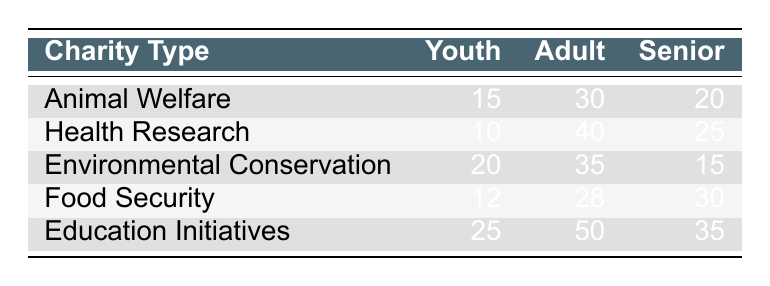What is the donation amount from Seniors to Food Security? In the table, the donation amount from Seniors for Food Security is indicated directly as 30.
Answer: 30 Which charity type received the highest donation from Adults? By looking across the Adult column, Education Initiatives has the highest amount of 50 compared to other charity types.
Answer: Education Initiatives What is the average donation amount from Youth across all charity types? To find the average, sum the values in the Youth column (15 + 10 + 20 + 12 + 25 = 92) and divide by the number of charity types (5). So, the average is 92 / 5 = 18.4.
Answer: 18.4 Did Seniors donate more to Animal Welfare than to Environmental Conservation? The table shows that Seniors donated 20 to Animal Welfare and 15 to Environmental Conservation, therefore, Seniors donated more to Animal Welfare.
Answer: Yes What is the total amount of donations made by Youth for all charity types? To calculate the total, we sum the Youth donations (15 + 10 + 20 + 12 + 25 = 92).
Answer: 92 Is the donation amount from Adults to Food Security greater than the donation from Youth to Health Research? The donation from Adults to Food Security is 28, while the donation from Youth to Health Research is 10. Since 28 is greater than 10, the statement is true.
Answer: Yes Which age group donated the least to Environmental Conservation? In the Environmental Conservation row, Youth donated 20, Adults donated 35, and Seniors donated 15. Since 15 is the least among these values, Seniors donated the least.
Answer: Seniors What is the difference between the donations made by Adults and Seniors in Health Research? For Health Research, Adults donated 40 and Seniors donated 25. To find the difference, we subtract: 40 - 25 = 15.
Answer: 15 In which charity type does Youth have the highest donation amount? By examining the Youth column, Education Initiatives shows the highest donation amount of 25 among the charity types.
Answer: Education Initiatives 